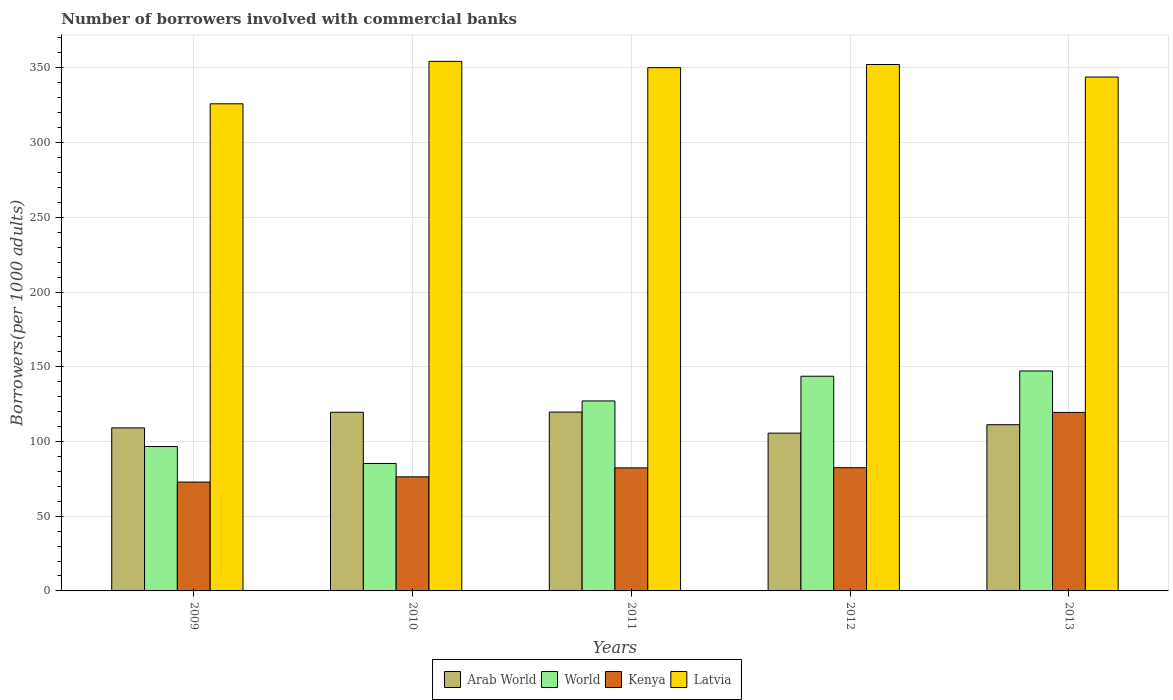Are the number of bars on each tick of the X-axis equal?
Your answer should be compact. Yes. How many bars are there on the 2nd tick from the left?
Give a very brief answer. 4. What is the label of the 1st group of bars from the left?
Offer a very short reply. 2009. In how many cases, is the number of bars for a given year not equal to the number of legend labels?
Offer a terse response. 0. What is the number of borrowers involved with commercial banks in Kenya in 2013?
Your answer should be compact. 119.46. Across all years, what is the maximum number of borrowers involved with commercial banks in World?
Your answer should be very brief. 147.17. Across all years, what is the minimum number of borrowers involved with commercial banks in Latvia?
Keep it short and to the point. 325.95. In which year was the number of borrowers involved with commercial banks in Latvia maximum?
Give a very brief answer. 2010. In which year was the number of borrowers involved with commercial banks in World minimum?
Provide a short and direct response. 2010. What is the total number of borrowers involved with commercial banks in Latvia in the graph?
Provide a succinct answer. 1726.58. What is the difference between the number of borrowers involved with commercial banks in Kenya in 2009 and that in 2012?
Provide a succinct answer. -9.6. What is the difference between the number of borrowers involved with commercial banks in Latvia in 2011 and the number of borrowers involved with commercial banks in World in 2010?
Your response must be concise. 264.85. What is the average number of borrowers involved with commercial banks in Arab World per year?
Give a very brief answer. 113.02. In the year 2009, what is the difference between the number of borrowers involved with commercial banks in World and number of borrowers involved with commercial banks in Kenya?
Your answer should be very brief. 23.76. What is the ratio of the number of borrowers involved with commercial banks in Arab World in 2012 to that in 2013?
Offer a very short reply. 0.95. Is the number of borrowers involved with commercial banks in Latvia in 2012 less than that in 2013?
Give a very brief answer. No. What is the difference between the highest and the second highest number of borrowers involved with commercial banks in Arab World?
Give a very brief answer. 0.13. What is the difference between the highest and the lowest number of borrowers involved with commercial banks in Latvia?
Ensure brevity in your answer.  28.41. In how many years, is the number of borrowers involved with commercial banks in Latvia greater than the average number of borrowers involved with commercial banks in Latvia taken over all years?
Offer a very short reply. 3. Is the sum of the number of borrowers involved with commercial banks in World in 2010 and 2012 greater than the maximum number of borrowers involved with commercial banks in Kenya across all years?
Make the answer very short. Yes. Is it the case that in every year, the sum of the number of borrowers involved with commercial banks in Latvia and number of borrowers involved with commercial banks in Arab World is greater than the sum of number of borrowers involved with commercial banks in Kenya and number of borrowers involved with commercial banks in World?
Give a very brief answer. Yes. What does the 1st bar from the left in 2012 represents?
Make the answer very short. Arab World. How many bars are there?
Provide a succinct answer. 20. What is the difference between two consecutive major ticks on the Y-axis?
Your answer should be very brief. 50. Are the values on the major ticks of Y-axis written in scientific E-notation?
Your response must be concise. No. Does the graph contain grids?
Provide a succinct answer. Yes. Where does the legend appear in the graph?
Make the answer very short. Bottom center. How many legend labels are there?
Your response must be concise. 4. How are the legend labels stacked?
Give a very brief answer. Horizontal. What is the title of the graph?
Ensure brevity in your answer.  Number of borrowers involved with commercial banks. Does "Middle East & North Africa (all income levels)" appear as one of the legend labels in the graph?
Keep it short and to the point. No. What is the label or title of the X-axis?
Provide a short and direct response. Years. What is the label or title of the Y-axis?
Provide a short and direct response. Borrowers(per 1000 adults). What is the Borrowers(per 1000 adults) of Arab World in 2009?
Your response must be concise. 109.1. What is the Borrowers(per 1000 adults) of World in 2009?
Offer a terse response. 96.61. What is the Borrowers(per 1000 adults) of Kenya in 2009?
Provide a succinct answer. 72.85. What is the Borrowers(per 1000 adults) in Latvia in 2009?
Keep it short and to the point. 325.95. What is the Borrowers(per 1000 adults) in Arab World in 2010?
Ensure brevity in your answer.  119.55. What is the Borrowers(per 1000 adults) in World in 2010?
Give a very brief answer. 85.29. What is the Borrowers(per 1000 adults) in Kenya in 2010?
Provide a succinct answer. 76.34. What is the Borrowers(per 1000 adults) in Latvia in 2010?
Make the answer very short. 354.36. What is the Borrowers(per 1000 adults) in Arab World in 2011?
Your response must be concise. 119.68. What is the Borrowers(per 1000 adults) in World in 2011?
Give a very brief answer. 127.13. What is the Borrowers(per 1000 adults) in Kenya in 2011?
Offer a very short reply. 82.34. What is the Borrowers(per 1000 adults) of Latvia in 2011?
Offer a terse response. 350.14. What is the Borrowers(per 1000 adults) in Arab World in 2012?
Your answer should be compact. 105.58. What is the Borrowers(per 1000 adults) of World in 2012?
Provide a short and direct response. 143.67. What is the Borrowers(per 1000 adults) in Kenya in 2012?
Your answer should be compact. 82.45. What is the Borrowers(per 1000 adults) of Latvia in 2012?
Make the answer very short. 352.26. What is the Borrowers(per 1000 adults) in Arab World in 2013?
Make the answer very short. 111.22. What is the Borrowers(per 1000 adults) of World in 2013?
Provide a short and direct response. 147.17. What is the Borrowers(per 1000 adults) in Kenya in 2013?
Offer a very short reply. 119.46. What is the Borrowers(per 1000 adults) of Latvia in 2013?
Offer a very short reply. 343.87. Across all years, what is the maximum Borrowers(per 1000 adults) in Arab World?
Your answer should be very brief. 119.68. Across all years, what is the maximum Borrowers(per 1000 adults) of World?
Keep it short and to the point. 147.17. Across all years, what is the maximum Borrowers(per 1000 adults) in Kenya?
Keep it short and to the point. 119.46. Across all years, what is the maximum Borrowers(per 1000 adults) in Latvia?
Ensure brevity in your answer.  354.36. Across all years, what is the minimum Borrowers(per 1000 adults) of Arab World?
Your answer should be compact. 105.58. Across all years, what is the minimum Borrowers(per 1000 adults) in World?
Offer a very short reply. 85.29. Across all years, what is the minimum Borrowers(per 1000 adults) in Kenya?
Offer a terse response. 72.85. Across all years, what is the minimum Borrowers(per 1000 adults) of Latvia?
Ensure brevity in your answer.  325.95. What is the total Borrowers(per 1000 adults) of Arab World in the graph?
Your answer should be compact. 565.12. What is the total Borrowers(per 1000 adults) of World in the graph?
Your response must be concise. 599.87. What is the total Borrowers(per 1000 adults) of Kenya in the graph?
Give a very brief answer. 433.43. What is the total Borrowers(per 1000 adults) of Latvia in the graph?
Ensure brevity in your answer.  1726.58. What is the difference between the Borrowers(per 1000 adults) of Arab World in 2009 and that in 2010?
Make the answer very short. -10.45. What is the difference between the Borrowers(per 1000 adults) of World in 2009 and that in 2010?
Your answer should be very brief. 11.32. What is the difference between the Borrowers(per 1000 adults) of Kenya in 2009 and that in 2010?
Provide a succinct answer. -3.49. What is the difference between the Borrowers(per 1000 adults) in Latvia in 2009 and that in 2010?
Provide a short and direct response. -28.41. What is the difference between the Borrowers(per 1000 adults) in Arab World in 2009 and that in 2011?
Provide a short and direct response. -10.58. What is the difference between the Borrowers(per 1000 adults) of World in 2009 and that in 2011?
Your response must be concise. -30.52. What is the difference between the Borrowers(per 1000 adults) of Kenya in 2009 and that in 2011?
Your answer should be very brief. -9.49. What is the difference between the Borrowers(per 1000 adults) in Latvia in 2009 and that in 2011?
Make the answer very short. -24.19. What is the difference between the Borrowers(per 1000 adults) of Arab World in 2009 and that in 2012?
Keep it short and to the point. 3.52. What is the difference between the Borrowers(per 1000 adults) in World in 2009 and that in 2012?
Give a very brief answer. -47.06. What is the difference between the Borrowers(per 1000 adults) of Kenya in 2009 and that in 2012?
Provide a short and direct response. -9.6. What is the difference between the Borrowers(per 1000 adults) in Latvia in 2009 and that in 2012?
Offer a very short reply. -26.3. What is the difference between the Borrowers(per 1000 adults) in Arab World in 2009 and that in 2013?
Give a very brief answer. -2.12. What is the difference between the Borrowers(per 1000 adults) in World in 2009 and that in 2013?
Ensure brevity in your answer.  -50.57. What is the difference between the Borrowers(per 1000 adults) in Kenya in 2009 and that in 2013?
Offer a very short reply. -46.61. What is the difference between the Borrowers(per 1000 adults) of Latvia in 2009 and that in 2013?
Your answer should be very brief. -17.92. What is the difference between the Borrowers(per 1000 adults) of Arab World in 2010 and that in 2011?
Give a very brief answer. -0.13. What is the difference between the Borrowers(per 1000 adults) in World in 2010 and that in 2011?
Give a very brief answer. -41.84. What is the difference between the Borrowers(per 1000 adults) of Kenya in 2010 and that in 2011?
Your response must be concise. -6. What is the difference between the Borrowers(per 1000 adults) in Latvia in 2010 and that in 2011?
Your answer should be very brief. 4.22. What is the difference between the Borrowers(per 1000 adults) of Arab World in 2010 and that in 2012?
Your answer should be compact. 13.97. What is the difference between the Borrowers(per 1000 adults) of World in 2010 and that in 2012?
Provide a succinct answer. -58.38. What is the difference between the Borrowers(per 1000 adults) in Kenya in 2010 and that in 2012?
Make the answer very short. -6.11. What is the difference between the Borrowers(per 1000 adults) of Latvia in 2010 and that in 2012?
Provide a succinct answer. 2.11. What is the difference between the Borrowers(per 1000 adults) of Arab World in 2010 and that in 2013?
Keep it short and to the point. 8.33. What is the difference between the Borrowers(per 1000 adults) in World in 2010 and that in 2013?
Ensure brevity in your answer.  -61.89. What is the difference between the Borrowers(per 1000 adults) of Kenya in 2010 and that in 2013?
Provide a short and direct response. -43.12. What is the difference between the Borrowers(per 1000 adults) in Latvia in 2010 and that in 2013?
Your answer should be compact. 10.49. What is the difference between the Borrowers(per 1000 adults) in Arab World in 2011 and that in 2012?
Ensure brevity in your answer.  14.1. What is the difference between the Borrowers(per 1000 adults) of World in 2011 and that in 2012?
Make the answer very short. -16.54. What is the difference between the Borrowers(per 1000 adults) of Kenya in 2011 and that in 2012?
Your answer should be compact. -0.11. What is the difference between the Borrowers(per 1000 adults) in Latvia in 2011 and that in 2012?
Offer a terse response. -2.12. What is the difference between the Borrowers(per 1000 adults) of Arab World in 2011 and that in 2013?
Offer a terse response. 8.46. What is the difference between the Borrowers(per 1000 adults) of World in 2011 and that in 2013?
Make the answer very short. -20.04. What is the difference between the Borrowers(per 1000 adults) of Kenya in 2011 and that in 2013?
Keep it short and to the point. -37.12. What is the difference between the Borrowers(per 1000 adults) in Latvia in 2011 and that in 2013?
Provide a short and direct response. 6.27. What is the difference between the Borrowers(per 1000 adults) of Arab World in 2012 and that in 2013?
Make the answer very short. -5.64. What is the difference between the Borrowers(per 1000 adults) in World in 2012 and that in 2013?
Offer a terse response. -3.51. What is the difference between the Borrowers(per 1000 adults) of Kenya in 2012 and that in 2013?
Provide a short and direct response. -37.01. What is the difference between the Borrowers(per 1000 adults) in Latvia in 2012 and that in 2013?
Offer a very short reply. 8.39. What is the difference between the Borrowers(per 1000 adults) of Arab World in 2009 and the Borrowers(per 1000 adults) of World in 2010?
Offer a very short reply. 23.81. What is the difference between the Borrowers(per 1000 adults) of Arab World in 2009 and the Borrowers(per 1000 adults) of Kenya in 2010?
Your answer should be very brief. 32.76. What is the difference between the Borrowers(per 1000 adults) of Arab World in 2009 and the Borrowers(per 1000 adults) of Latvia in 2010?
Ensure brevity in your answer.  -245.26. What is the difference between the Borrowers(per 1000 adults) of World in 2009 and the Borrowers(per 1000 adults) of Kenya in 2010?
Keep it short and to the point. 20.27. What is the difference between the Borrowers(per 1000 adults) of World in 2009 and the Borrowers(per 1000 adults) of Latvia in 2010?
Give a very brief answer. -257.75. What is the difference between the Borrowers(per 1000 adults) in Kenya in 2009 and the Borrowers(per 1000 adults) in Latvia in 2010?
Make the answer very short. -281.51. What is the difference between the Borrowers(per 1000 adults) in Arab World in 2009 and the Borrowers(per 1000 adults) in World in 2011?
Make the answer very short. -18.03. What is the difference between the Borrowers(per 1000 adults) in Arab World in 2009 and the Borrowers(per 1000 adults) in Kenya in 2011?
Give a very brief answer. 26.76. What is the difference between the Borrowers(per 1000 adults) in Arab World in 2009 and the Borrowers(per 1000 adults) in Latvia in 2011?
Make the answer very short. -241.04. What is the difference between the Borrowers(per 1000 adults) in World in 2009 and the Borrowers(per 1000 adults) in Kenya in 2011?
Offer a terse response. 14.27. What is the difference between the Borrowers(per 1000 adults) in World in 2009 and the Borrowers(per 1000 adults) in Latvia in 2011?
Offer a very short reply. -253.53. What is the difference between the Borrowers(per 1000 adults) of Kenya in 2009 and the Borrowers(per 1000 adults) of Latvia in 2011?
Your answer should be very brief. -277.29. What is the difference between the Borrowers(per 1000 adults) in Arab World in 2009 and the Borrowers(per 1000 adults) in World in 2012?
Keep it short and to the point. -34.57. What is the difference between the Borrowers(per 1000 adults) in Arab World in 2009 and the Borrowers(per 1000 adults) in Kenya in 2012?
Your answer should be very brief. 26.65. What is the difference between the Borrowers(per 1000 adults) in Arab World in 2009 and the Borrowers(per 1000 adults) in Latvia in 2012?
Offer a terse response. -243.16. What is the difference between the Borrowers(per 1000 adults) of World in 2009 and the Borrowers(per 1000 adults) of Kenya in 2012?
Ensure brevity in your answer.  14.16. What is the difference between the Borrowers(per 1000 adults) in World in 2009 and the Borrowers(per 1000 adults) in Latvia in 2012?
Provide a short and direct response. -255.65. What is the difference between the Borrowers(per 1000 adults) in Kenya in 2009 and the Borrowers(per 1000 adults) in Latvia in 2012?
Ensure brevity in your answer.  -279.41. What is the difference between the Borrowers(per 1000 adults) of Arab World in 2009 and the Borrowers(per 1000 adults) of World in 2013?
Ensure brevity in your answer.  -38.08. What is the difference between the Borrowers(per 1000 adults) of Arab World in 2009 and the Borrowers(per 1000 adults) of Kenya in 2013?
Your answer should be very brief. -10.36. What is the difference between the Borrowers(per 1000 adults) of Arab World in 2009 and the Borrowers(per 1000 adults) of Latvia in 2013?
Your answer should be very brief. -234.77. What is the difference between the Borrowers(per 1000 adults) of World in 2009 and the Borrowers(per 1000 adults) of Kenya in 2013?
Your response must be concise. -22.85. What is the difference between the Borrowers(per 1000 adults) of World in 2009 and the Borrowers(per 1000 adults) of Latvia in 2013?
Give a very brief answer. -247.26. What is the difference between the Borrowers(per 1000 adults) of Kenya in 2009 and the Borrowers(per 1000 adults) of Latvia in 2013?
Ensure brevity in your answer.  -271.02. What is the difference between the Borrowers(per 1000 adults) of Arab World in 2010 and the Borrowers(per 1000 adults) of World in 2011?
Ensure brevity in your answer.  -7.58. What is the difference between the Borrowers(per 1000 adults) of Arab World in 2010 and the Borrowers(per 1000 adults) of Kenya in 2011?
Ensure brevity in your answer.  37.21. What is the difference between the Borrowers(per 1000 adults) of Arab World in 2010 and the Borrowers(per 1000 adults) of Latvia in 2011?
Ensure brevity in your answer.  -230.59. What is the difference between the Borrowers(per 1000 adults) in World in 2010 and the Borrowers(per 1000 adults) in Kenya in 2011?
Ensure brevity in your answer.  2.95. What is the difference between the Borrowers(per 1000 adults) of World in 2010 and the Borrowers(per 1000 adults) of Latvia in 2011?
Offer a terse response. -264.85. What is the difference between the Borrowers(per 1000 adults) in Kenya in 2010 and the Borrowers(per 1000 adults) in Latvia in 2011?
Offer a very short reply. -273.8. What is the difference between the Borrowers(per 1000 adults) in Arab World in 2010 and the Borrowers(per 1000 adults) in World in 2012?
Make the answer very short. -24.12. What is the difference between the Borrowers(per 1000 adults) in Arab World in 2010 and the Borrowers(per 1000 adults) in Kenya in 2012?
Make the answer very short. 37.1. What is the difference between the Borrowers(per 1000 adults) of Arab World in 2010 and the Borrowers(per 1000 adults) of Latvia in 2012?
Ensure brevity in your answer.  -232.71. What is the difference between the Borrowers(per 1000 adults) in World in 2010 and the Borrowers(per 1000 adults) in Kenya in 2012?
Your response must be concise. 2.84. What is the difference between the Borrowers(per 1000 adults) in World in 2010 and the Borrowers(per 1000 adults) in Latvia in 2012?
Provide a short and direct response. -266.97. What is the difference between the Borrowers(per 1000 adults) of Kenya in 2010 and the Borrowers(per 1000 adults) of Latvia in 2012?
Provide a short and direct response. -275.92. What is the difference between the Borrowers(per 1000 adults) of Arab World in 2010 and the Borrowers(per 1000 adults) of World in 2013?
Make the answer very short. -27.63. What is the difference between the Borrowers(per 1000 adults) of Arab World in 2010 and the Borrowers(per 1000 adults) of Kenya in 2013?
Your response must be concise. 0.09. What is the difference between the Borrowers(per 1000 adults) of Arab World in 2010 and the Borrowers(per 1000 adults) of Latvia in 2013?
Provide a short and direct response. -224.32. What is the difference between the Borrowers(per 1000 adults) in World in 2010 and the Borrowers(per 1000 adults) in Kenya in 2013?
Your response must be concise. -34.17. What is the difference between the Borrowers(per 1000 adults) in World in 2010 and the Borrowers(per 1000 adults) in Latvia in 2013?
Offer a terse response. -258.58. What is the difference between the Borrowers(per 1000 adults) in Kenya in 2010 and the Borrowers(per 1000 adults) in Latvia in 2013?
Offer a terse response. -267.53. What is the difference between the Borrowers(per 1000 adults) in Arab World in 2011 and the Borrowers(per 1000 adults) in World in 2012?
Make the answer very short. -23.99. What is the difference between the Borrowers(per 1000 adults) of Arab World in 2011 and the Borrowers(per 1000 adults) of Kenya in 2012?
Offer a very short reply. 37.23. What is the difference between the Borrowers(per 1000 adults) of Arab World in 2011 and the Borrowers(per 1000 adults) of Latvia in 2012?
Your answer should be compact. -232.58. What is the difference between the Borrowers(per 1000 adults) in World in 2011 and the Borrowers(per 1000 adults) in Kenya in 2012?
Make the answer very short. 44.68. What is the difference between the Borrowers(per 1000 adults) of World in 2011 and the Borrowers(per 1000 adults) of Latvia in 2012?
Provide a succinct answer. -225.13. What is the difference between the Borrowers(per 1000 adults) of Kenya in 2011 and the Borrowers(per 1000 adults) of Latvia in 2012?
Provide a succinct answer. -269.92. What is the difference between the Borrowers(per 1000 adults) in Arab World in 2011 and the Borrowers(per 1000 adults) in World in 2013?
Ensure brevity in your answer.  -27.5. What is the difference between the Borrowers(per 1000 adults) of Arab World in 2011 and the Borrowers(per 1000 adults) of Kenya in 2013?
Provide a succinct answer. 0.22. What is the difference between the Borrowers(per 1000 adults) of Arab World in 2011 and the Borrowers(per 1000 adults) of Latvia in 2013?
Provide a succinct answer. -224.19. What is the difference between the Borrowers(per 1000 adults) of World in 2011 and the Borrowers(per 1000 adults) of Kenya in 2013?
Keep it short and to the point. 7.67. What is the difference between the Borrowers(per 1000 adults) in World in 2011 and the Borrowers(per 1000 adults) in Latvia in 2013?
Your answer should be compact. -216.74. What is the difference between the Borrowers(per 1000 adults) in Kenya in 2011 and the Borrowers(per 1000 adults) in Latvia in 2013?
Ensure brevity in your answer.  -261.53. What is the difference between the Borrowers(per 1000 adults) of Arab World in 2012 and the Borrowers(per 1000 adults) of World in 2013?
Your response must be concise. -41.59. What is the difference between the Borrowers(per 1000 adults) of Arab World in 2012 and the Borrowers(per 1000 adults) of Kenya in 2013?
Make the answer very short. -13.88. What is the difference between the Borrowers(per 1000 adults) of Arab World in 2012 and the Borrowers(per 1000 adults) of Latvia in 2013?
Make the answer very short. -238.29. What is the difference between the Borrowers(per 1000 adults) of World in 2012 and the Borrowers(per 1000 adults) of Kenya in 2013?
Provide a succinct answer. 24.21. What is the difference between the Borrowers(per 1000 adults) in World in 2012 and the Borrowers(per 1000 adults) in Latvia in 2013?
Your answer should be compact. -200.2. What is the difference between the Borrowers(per 1000 adults) of Kenya in 2012 and the Borrowers(per 1000 adults) of Latvia in 2013?
Keep it short and to the point. -261.42. What is the average Borrowers(per 1000 adults) in Arab World per year?
Offer a terse response. 113.02. What is the average Borrowers(per 1000 adults) of World per year?
Your answer should be very brief. 119.97. What is the average Borrowers(per 1000 adults) of Kenya per year?
Give a very brief answer. 86.69. What is the average Borrowers(per 1000 adults) of Latvia per year?
Ensure brevity in your answer.  345.32. In the year 2009, what is the difference between the Borrowers(per 1000 adults) of Arab World and Borrowers(per 1000 adults) of World?
Offer a very short reply. 12.49. In the year 2009, what is the difference between the Borrowers(per 1000 adults) of Arab World and Borrowers(per 1000 adults) of Kenya?
Your answer should be very brief. 36.25. In the year 2009, what is the difference between the Borrowers(per 1000 adults) of Arab World and Borrowers(per 1000 adults) of Latvia?
Your answer should be compact. -216.85. In the year 2009, what is the difference between the Borrowers(per 1000 adults) of World and Borrowers(per 1000 adults) of Kenya?
Offer a terse response. 23.76. In the year 2009, what is the difference between the Borrowers(per 1000 adults) of World and Borrowers(per 1000 adults) of Latvia?
Offer a terse response. -229.34. In the year 2009, what is the difference between the Borrowers(per 1000 adults) of Kenya and Borrowers(per 1000 adults) of Latvia?
Provide a short and direct response. -253.1. In the year 2010, what is the difference between the Borrowers(per 1000 adults) of Arab World and Borrowers(per 1000 adults) of World?
Offer a terse response. 34.26. In the year 2010, what is the difference between the Borrowers(per 1000 adults) in Arab World and Borrowers(per 1000 adults) in Kenya?
Make the answer very short. 43.21. In the year 2010, what is the difference between the Borrowers(per 1000 adults) of Arab World and Borrowers(per 1000 adults) of Latvia?
Your answer should be compact. -234.81. In the year 2010, what is the difference between the Borrowers(per 1000 adults) of World and Borrowers(per 1000 adults) of Kenya?
Ensure brevity in your answer.  8.95. In the year 2010, what is the difference between the Borrowers(per 1000 adults) of World and Borrowers(per 1000 adults) of Latvia?
Provide a short and direct response. -269.08. In the year 2010, what is the difference between the Borrowers(per 1000 adults) of Kenya and Borrowers(per 1000 adults) of Latvia?
Your answer should be very brief. -278.02. In the year 2011, what is the difference between the Borrowers(per 1000 adults) in Arab World and Borrowers(per 1000 adults) in World?
Your answer should be very brief. -7.45. In the year 2011, what is the difference between the Borrowers(per 1000 adults) of Arab World and Borrowers(per 1000 adults) of Kenya?
Your answer should be very brief. 37.34. In the year 2011, what is the difference between the Borrowers(per 1000 adults) in Arab World and Borrowers(per 1000 adults) in Latvia?
Provide a short and direct response. -230.46. In the year 2011, what is the difference between the Borrowers(per 1000 adults) of World and Borrowers(per 1000 adults) of Kenya?
Offer a very short reply. 44.79. In the year 2011, what is the difference between the Borrowers(per 1000 adults) in World and Borrowers(per 1000 adults) in Latvia?
Your answer should be very brief. -223.01. In the year 2011, what is the difference between the Borrowers(per 1000 adults) of Kenya and Borrowers(per 1000 adults) of Latvia?
Provide a short and direct response. -267.8. In the year 2012, what is the difference between the Borrowers(per 1000 adults) in Arab World and Borrowers(per 1000 adults) in World?
Give a very brief answer. -38.09. In the year 2012, what is the difference between the Borrowers(per 1000 adults) of Arab World and Borrowers(per 1000 adults) of Kenya?
Give a very brief answer. 23.13. In the year 2012, what is the difference between the Borrowers(per 1000 adults) of Arab World and Borrowers(per 1000 adults) of Latvia?
Offer a very short reply. -246.68. In the year 2012, what is the difference between the Borrowers(per 1000 adults) in World and Borrowers(per 1000 adults) in Kenya?
Your answer should be very brief. 61.22. In the year 2012, what is the difference between the Borrowers(per 1000 adults) in World and Borrowers(per 1000 adults) in Latvia?
Your answer should be very brief. -208.59. In the year 2012, what is the difference between the Borrowers(per 1000 adults) of Kenya and Borrowers(per 1000 adults) of Latvia?
Ensure brevity in your answer.  -269.81. In the year 2013, what is the difference between the Borrowers(per 1000 adults) of Arab World and Borrowers(per 1000 adults) of World?
Offer a terse response. -35.96. In the year 2013, what is the difference between the Borrowers(per 1000 adults) in Arab World and Borrowers(per 1000 adults) in Kenya?
Your response must be concise. -8.24. In the year 2013, what is the difference between the Borrowers(per 1000 adults) of Arab World and Borrowers(per 1000 adults) of Latvia?
Ensure brevity in your answer.  -232.65. In the year 2013, what is the difference between the Borrowers(per 1000 adults) of World and Borrowers(per 1000 adults) of Kenya?
Make the answer very short. 27.71. In the year 2013, what is the difference between the Borrowers(per 1000 adults) of World and Borrowers(per 1000 adults) of Latvia?
Your answer should be compact. -196.69. In the year 2013, what is the difference between the Borrowers(per 1000 adults) of Kenya and Borrowers(per 1000 adults) of Latvia?
Provide a succinct answer. -224.41. What is the ratio of the Borrowers(per 1000 adults) of Arab World in 2009 to that in 2010?
Offer a terse response. 0.91. What is the ratio of the Borrowers(per 1000 adults) of World in 2009 to that in 2010?
Your answer should be compact. 1.13. What is the ratio of the Borrowers(per 1000 adults) of Kenya in 2009 to that in 2010?
Provide a succinct answer. 0.95. What is the ratio of the Borrowers(per 1000 adults) of Latvia in 2009 to that in 2010?
Provide a succinct answer. 0.92. What is the ratio of the Borrowers(per 1000 adults) in Arab World in 2009 to that in 2011?
Keep it short and to the point. 0.91. What is the ratio of the Borrowers(per 1000 adults) of World in 2009 to that in 2011?
Keep it short and to the point. 0.76. What is the ratio of the Borrowers(per 1000 adults) in Kenya in 2009 to that in 2011?
Keep it short and to the point. 0.88. What is the ratio of the Borrowers(per 1000 adults) in Latvia in 2009 to that in 2011?
Your answer should be compact. 0.93. What is the ratio of the Borrowers(per 1000 adults) in World in 2009 to that in 2012?
Your answer should be compact. 0.67. What is the ratio of the Borrowers(per 1000 adults) in Kenya in 2009 to that in 2012?
Provide a succinct answer. 0.88. What is the ratio of the Borrowers(per 1000 adults) of Latvia in 2009 to that in 2012?
Offer a very short reply. 0.93. What is the ratio of the Borrowers(per 1000 adults) of Arab World in 2009 to that in 2013?
Make the answer very short. 0.98. What is the ratio of the Borrowers(per 1000 adults) in World in 2009 to that in 2013?
Offer a very short reply. 0.66. What is the ratio of the Borrowers(per 1000 adults) of Kenya in 2009 to that in 2013?
Offer a very short reply. 0.61. What is the ratio of the Borrowers(per 1000 adults) in Latvia in 2009 to that in 2013?
Your response must be concise. 0.95. What is the ratio of the Borrowers(per 1000 adults) in World in 2010 to that in 2011?
Offer a very short reply. 0.67. What is the ratio of the Borrowers(per 1000 adults) of Kenya in 2010 to that in 2011?
Give a very brief answer. 0.93. What is the ratio of the Borrowers(per 1000 adults) of Latvia in 2010 to that in 2011?
Provide a succinct answer. 1.01. What is the ratio of the Borrowers(per 1000 adults) in Arab World in 2010 to that in 2012?
Offer a very short reply. 1.13. What is the ratio of the Borrowers(per 1000 adults) in World in 2010 to that in 2012?
Ensure brevity in your answer.  0.59. What is the ratio of the Borrowers(per 1000 adults) of Kenya in 2010 to that in 2012?
Give a very brief answer. 0.93. What is the ratio of the Borrowers(per 1000 adults) in Latvia in 2010 to that in 2012?
Keep it short and to the point. 1.01. What is the ratio of the Borrowers(per 1000 adults) of Arab World in 2010 to that in 2013?
Your response must be concise. 1.07. What is the ratio of the Borrowers(per 1000 adults) of World in 2010 to that in 2013?
Your answer should be very brief. 0.58. What is the ratio of the Borrowers(per 1000 adults) of Kenya in 2010 to that in 2013?
Your answer should be very brief. 0.64. What is the ratio of the Borrowers(per 1000 adults) in Latvia in 2010 to that in 2013?
Keep it short and to the point. 1.03. What is the ratio of the Borrowers(per 1000 adults) of Arab World in 2011 to that in 2012?
Give a very brief answer. 1.13. What is the ratio of the Borrowers(per 1000 adults) in World in 2011 to that in 2012?
Give a very brief answer. 0.88. What is the ratio of the Borrowers(per 1000 adults) of Arab World in 2011 to that in 2013?
Your answer should be compact. 1.08. What is the ratio of the Borrowers(per 1000 adults) of World in 2011 to that in 2013?
Provide a short and direct response. 0.86. What is the ratio of the Borrowers(per 1000 adults) of Kenya in 2011 to that in 2013?
Ensure brevity in your answer.  0.69. What is the ratio of the Borrowers(per 1000 adults) in Latvia in 2011 to that in 2013?
Give a very brief answer. 1.02. What is the ratio of the Borrowers(per 1000 adults) in Arab World in 2012 to that in 2013?
Your answer should be very brief. 0.95. What is the ratio of the Borrowers(per 1000 adults) of World in 2012 to that in 2013?
Give a very brief answer. 0.98. What is the ratio of the Borrowers(per 1000 adults) in Kenya in 2012 to that in 2013?
Give a very brief answer. 0.69. What is the ratio of the Borrowers(per 1000 adults) in Latvia in 2012 to that in 2013?
Provide a succinct answer. 1.02. What is the difference between the highest and the second highest Borrowers(per 1000 adults) in Arab World?
Your answer should be compact. 0.13. What is the difference between the highest and the second highest Borrowers(per 1000 adults) in World?
Offer a very short reply. 3.51. What is the difference between the highest and the second highest Borrowers(per 1000 adults) in Kenya?
Offer a very short reply. 37.01. What is the difference between the highest and the second highest Borrowers(per 1000 adults) in Latvia?
Offer a terse response. 2.11. What is the difference between the highest and the lowest Borrowers(per 1000 adults) in Arab World?
Your answer should be compact. 14.1. What is the difference between the highest and the lowest Borrowers(per 1000 adults) in World?
Ensure brevity in your answer.  61.89. What is the difference between the highest and the lowest Borrowers(per 1000 adults) in Kenya?
Make the answer very short. 46.61. What is the difference between the highest and the lowest Borrowers(per 1000 adults) of Latvia?
Ensure brevity in your answer.  28.41. 